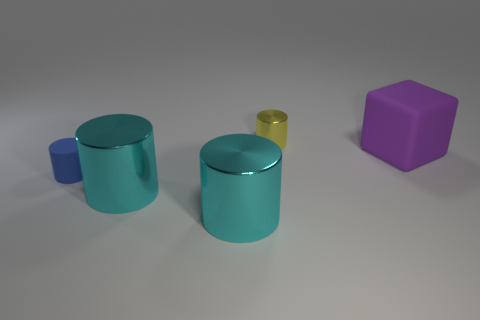Subtract all tiny yellow metallic cylinders. How many cylinders are left? 3 Subtract all brown balls. How many cyan cylinders are left? 2 Add 1 tiny blue matte spheres. How many objects exist? 6 Subtract all yellow cylinders. How many cylinders are left? 3 Subtract all cubes. How many objects are left? 4 Subtract 2 cylinders. How many cylinders are left? 2 Add 2 large purple cubes. How many large purple cubes exist? 3 Subtract 0 brown spheres. How many objects are left? 5 Subtract all purple cylinders. Subtract all brown blocks. How many cylinders are left? 4 Subtract all cyan cylinders. Subtract all big purple rubber objects. How many objects are left? 2 